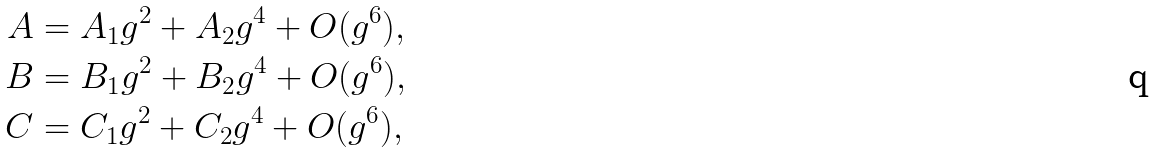Convert formula to latex. <formula><loc_0><loc_0><loc_500><loc_500>A & = A _ { 1 } g ^ { 2 } + A _ { 2 } g ^ { 4 } + O ( g ^ { 6 } ) , \\ B & = B _ { 1 } g ^ { 2 } + B _ { 2 } g ^ { 4 } + O ( g ^ { 6 } ) , \\ C & = C _ { 1 } g ^ { 2 } + C _ { 2 } g ^ { 4 } + O ( g ^ { 6 } ) ,</formula> 